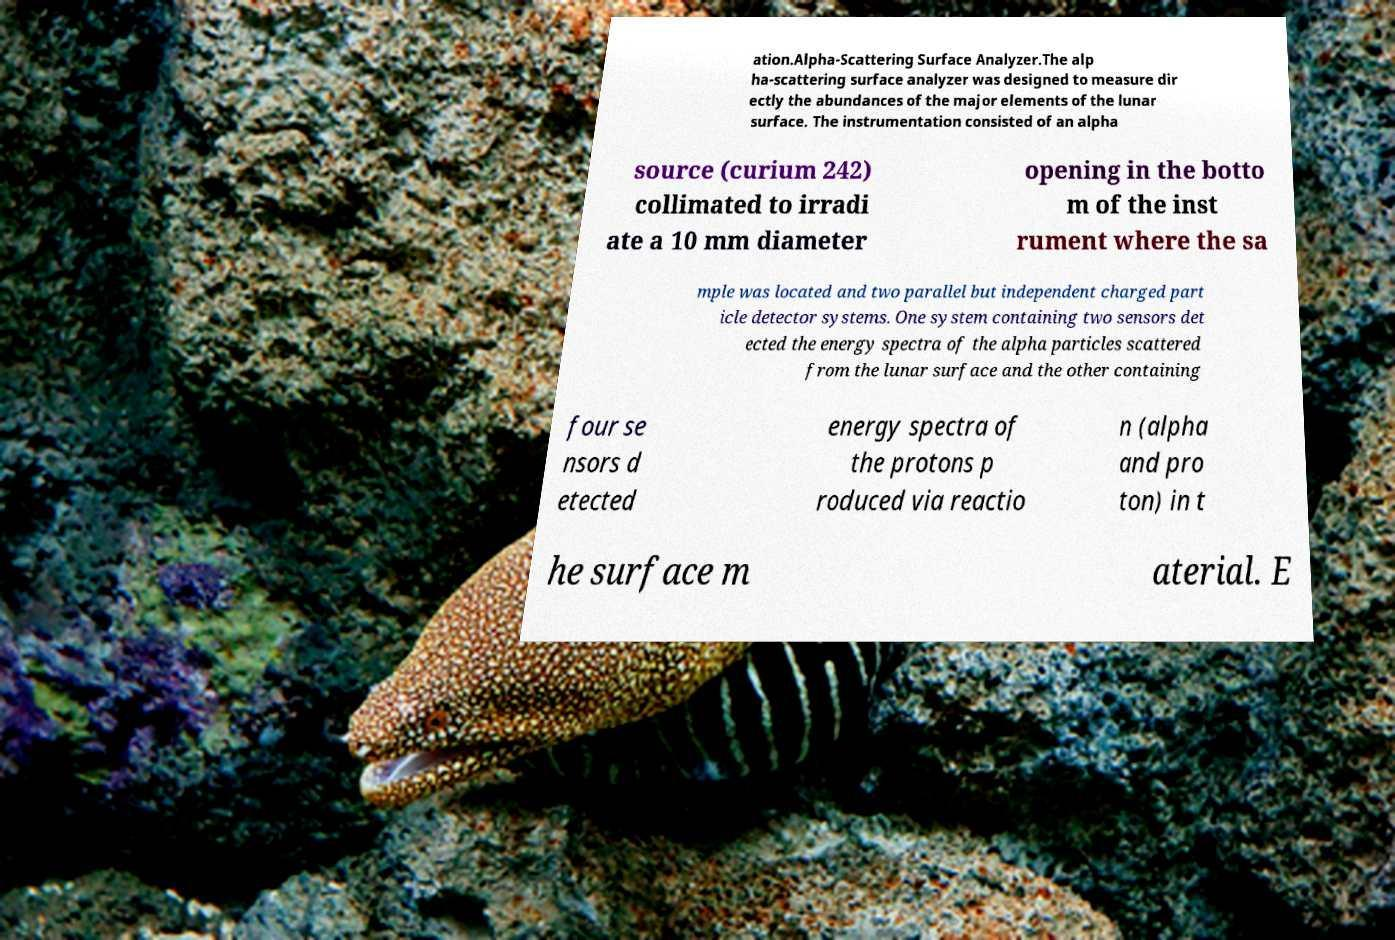For documentation purposes, I need the text within this image transcribed. Could you provide that? ation.Alpha-Scattering Surface Analyzer.The alp ha-scattering surface analyzer was designed to measure dir ectly the abundances of the major elements of the lunar surface. The instrumentation consisted of an alpha source (curium 242) collimated to irradi ate a 10 mm diameter opening in the botto m of the inst rument where the sa mple was located and two parallel but independent charged part icle detector systems. One system containing two sensors det ected the energy spectra of the alpha particles scattered from the lunar surface and the other containing four se nsors d etected energy spectra of the protons p roduced via reactio n (alpha and pro ton) in t he surface m aterial. E 